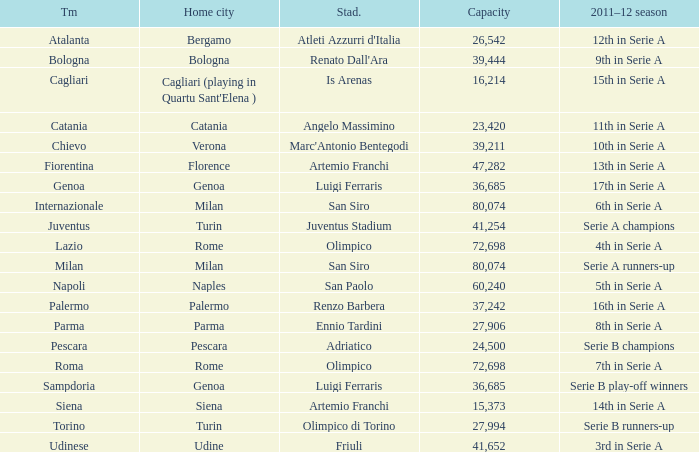What team had a capacity of over 26,542, a home city of milan, and finished the 2011-2012 season 6th in serie a? Internazionale. Can you give me this table as a dict? {'header': ['Tm', 'Home city', 'Stad.', 'Capacity', '2011–12 season'], 'rows': [['Atalanta', 'Bergamo', "Atleti Azzurri d'Italia", '26,542', '12th in Serie A'], ['Bologna', 'Bologna', "Renato Dall'Ara", '39,444', '9th in Serie A'], ['Cagliari', "Cagliari (playing in Quartu Sant'Elena )", 'Is Arenas', '16,214', '15th in Serie A'], ['Catania', 'Catania', 'Angelo Massimino', '23,420', '11th in Serie A'], ['Chievo', 'Verona', "Marc'Antonio Bentegodi", '39,211', '10th in Serie A'], ['Fiorentina', 'Florence', 'Artemio Franchi', '47,282', '13th in Serie A'], ['Genoa', 'Genoa', 'Luigi Ferraris', '36,685', '17th in Serie A'], ['Internazionale', 'Milan', 'San Siro', '80,074', '6th in Serie A'], ['Juventus', 'Turin', 'Juventus Stadium', '41,254', 'Serie A champions'], ['Lazio', 'Rome', 'Olimpico', '72,698', '4th in Serie A'], ['Milan', 'Milan', 'San Siro', '80,074', 'Serie A runners-up'], ['Napoli', 'Naples', 'San Paolo', '60,240', '5th in Serie A'], ['Palermo', 'Palermo', 'Renzo Barbera', '37,242', '16th in Serie A'], ['Parma', 'Parma', 'Ennio Tardini', '27,906', '8th in Serie A'], ['Pescara', 'Pescara', 'Adriatico', '24,500', 'Serie B champions'], ['Roma', 'Rome', 'Olimpico', '72,698', '7th in Serie A'], ['Sampdoria', 'Genoa', 'Luigi Ferraris', '36,685', 'Serie B play-off winners'], ['Siena', 'Siena', 'Artemio Franchi', '15,373', '14th in Serie A'], ['Torino', 'Turin', 'Olimpico di Torino', '27,994', 'Serie B runners-up'], ['Udinese', 'Udine', 'Friuli', '41,652', '3rd in Serie A']]} 